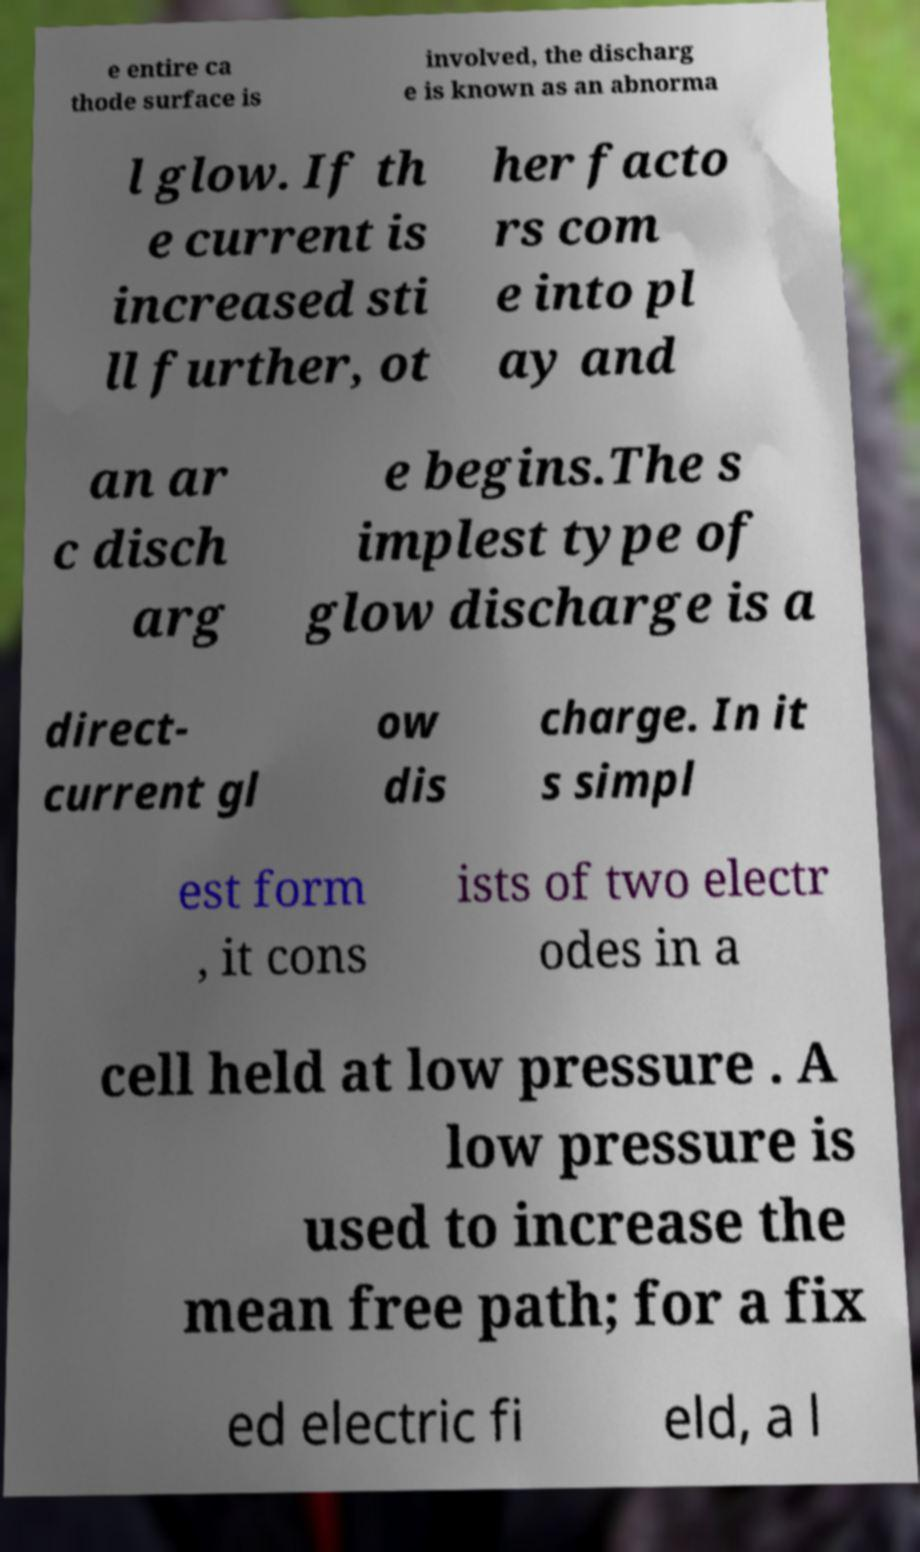For documentation purposes, I need the text within this image transcribed. Could you provide that? e entire ca thode surface is involved, the discharg e is known as an abnorma l glow. If th e current is increased sti ll further, ot her facto rs com e into pl ay and an ar c disch arg e begins.The s implest type of glow discharge is a direct- current gl ow dis charge. In it s simpl est form , it cons ists of two electr odes in a cell held at low pressure . A low pressure is used to increase the mean free path; for a fix ed electric fi eld, a l 